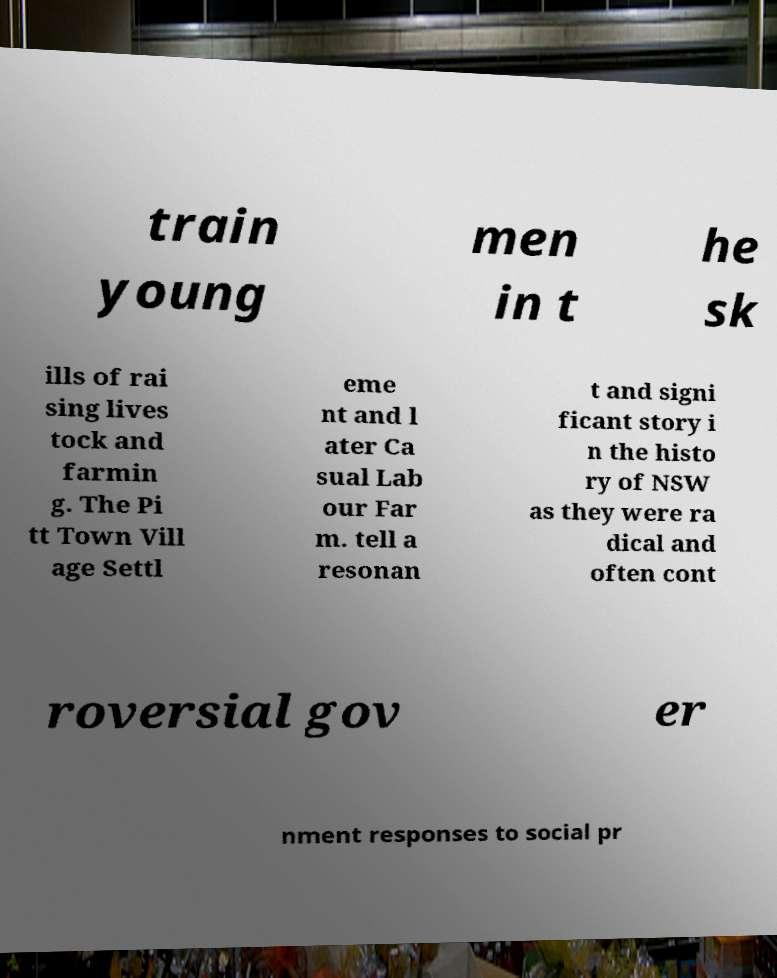There's text embedded in this image that I need extracted. Can you transcribe it verbatim? train young men in t he sk ills of rai sing lives tock and farmin g. The Pi tt Town Vill age Settl eme nt and l ater Ca sual Lab our Far m. tell a resonan t and signi ficant story i n the histo ry of NSW as they were ra dical and often cont roversial gov er nment responses to social pr 